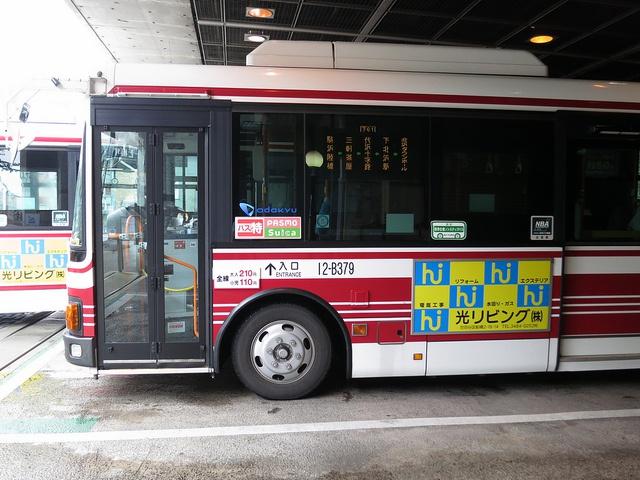Describe the objects in this image and their specific colors. I can see bus in white, black, gray, lightgray, and darkgray tones and bus in white, gray, and lightblue tones in this image. 